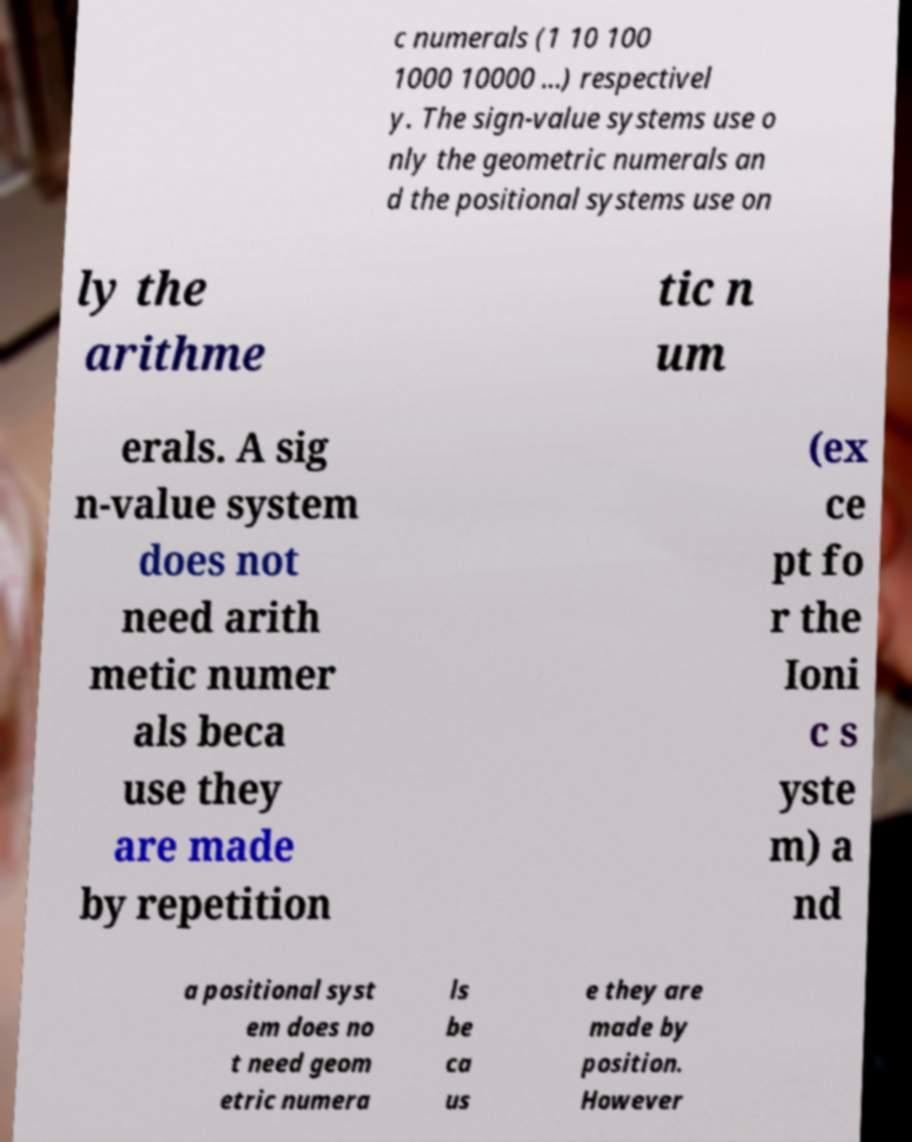Could you assist in decoding the text presented in this image and type it out clearly? c numerals (1 10 100 1000 10000 ...) respectivel y. The sign-value systems use o nly the geometric numerals an d the positional systems use on ly the arithme tic n um erals. A sig n-value system does not need arith metic numer als beca use they are made by repetition (ex ce pt fo r the Ioni c s yste m) a nd a positional syst em does no t need geom etric numera ls be ca us e they are made by position. However 